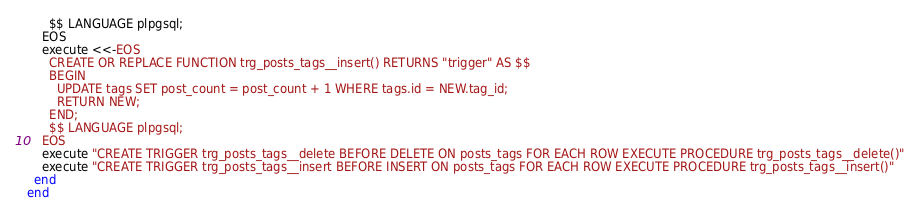Convert code to text. <code><loc_0><loc_0><loc_500><loc_500><_Ruby_>      $$ LANGUAGE plpgsql;
    EOS
    execute <<-EOS
      CREATE OR REPLACE FUNCTION trg_posts_tags__insert() RETURNS "trigger" AS $$
      BEGIN
        UPDATE tags SET post_count = post_count + 1 WHERE tags.id = NEW.tag_id;
        RETURN NEW;
      END;
      $$ LANGUAGE plpgsql;
    EOS
    execute "CREATE TRIGGER trg_posts_tags__delete BEFORE DELETE ON posts_tags FOR EACH ROW EXECUTE PROCEDURE trg_posts_tags__delete()"
    execute "CREATE TRIGGER trg_posts_tags__insert BEFORE INSERT ON posts_tags FOR EACH ROW EXECUTE PROCEDURE trg_posts_tags__insert()"
  end
end
</code> 